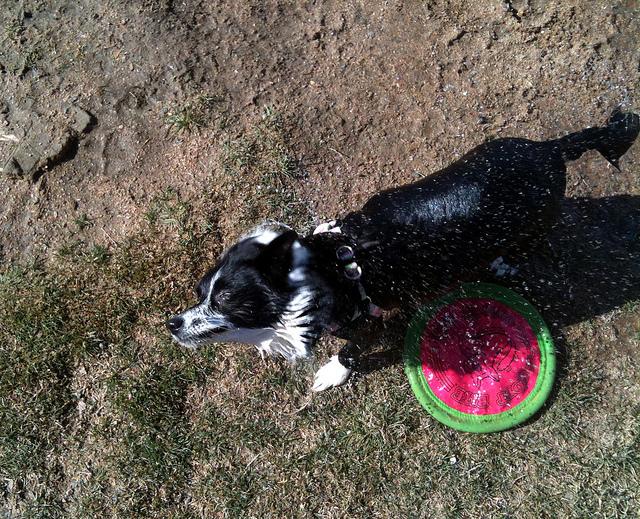Is the dog shaking?
Answer briefly. Yes. Is that a Frisbee next to the dog?
Be succinct. Yes. Is this dog a Labrador?
Short answer required. No. Is the grass green?
Concise answer only. No. What is the dog walking on?
Give a very brief answer. Grass. 